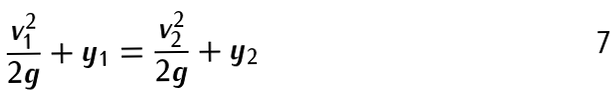Convert formula to latex. <formula><loc_0><loc_0><loc_500><loc_500>\frac { v _ { 1 } ^ { 2 } } { 2 g } + y _ { 1 } = \frac { v _ { 2 } ^ { 2 } } { 2 g } + y _ { 2 }</formula> 